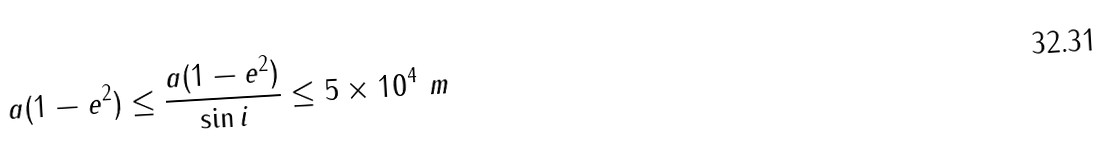Convert formula to latex. <formula><loc_0><loc_0><loc_500><loc_500>a ( 1 - e ^ { 2 } ) \leq \frac { a ( 1 - e ^ { 2 } ) } { \sin i } \leq 5 \times 1 0 ^ { 4 } \ m</formula> 